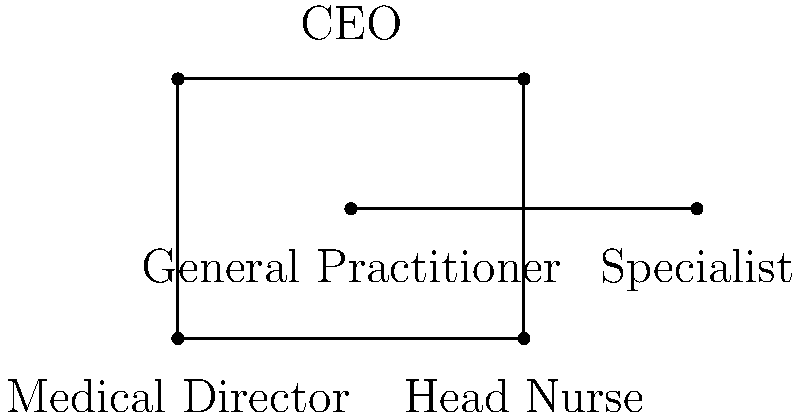In the simplified organizational chart of Pinn Medical Centre, which segments representing staff positions are congruent? To determine which segments are congruent in this organizational chart, we need to compare the lengths of the line segments connecting different positions. Let's analyze the chart step-by-step:

1. The chart is rectangular, with the CEO at the top center.

2. The Medical Director and Head Nurse are positioned at the bottom left and right corners, respectively. The segment connecting these two positions forms the base of the rectangle.

3. The General Practitioner and Specialist positions are on a horizontal line in the middle of the chart.

4. We can identify the following key segments:
   a) CEO to Medical Director (AC)
   b) CEO to Head Nurse (BD)
   c) Medical Director to General Practitioner (AE)
   d) Head Nurse to General Practitioner (BE)
   e) General Practitioner to Specialist (EF)

5. In a rectangle, opposite sides are congruent. Therefore, AC is congruent to BD.

6. The General Practitioner position (E) appears to be in the center of the base of the rectangle. This means AE is congruent to BE.

7. There's not enough information to determine if EF is congruent to any other segment.

Therefore, the congruent segments are:
- CEO to Medical Director (AC) and CEO to Head Nurse (BD)
- Medical Director to General Practitioner (AE) and Head Nurse to General Practitioner (BE)
Answer: AC ≅ BD, AE ≅ BE 